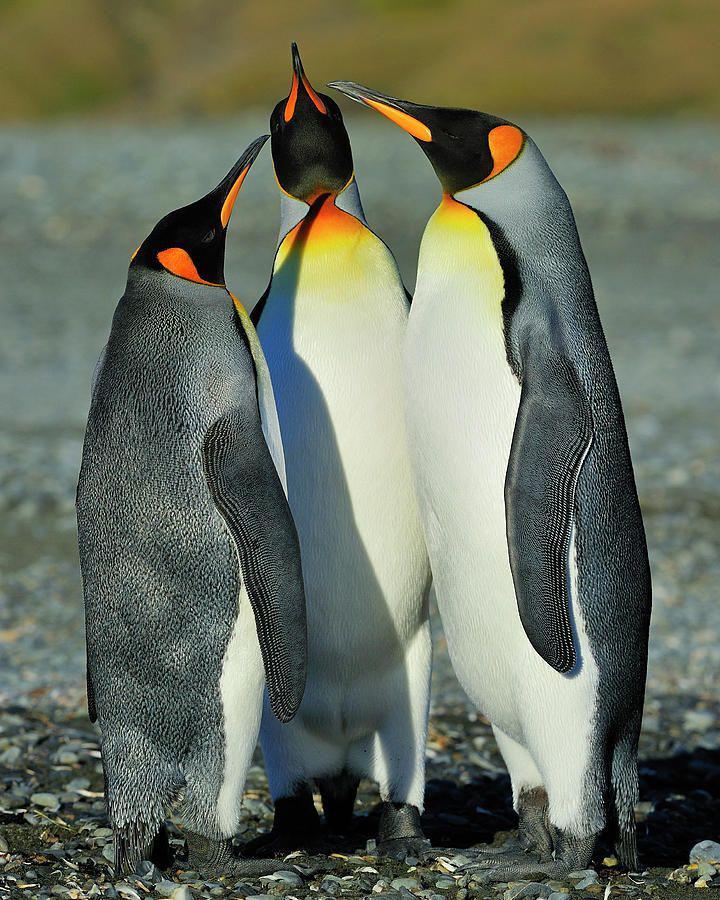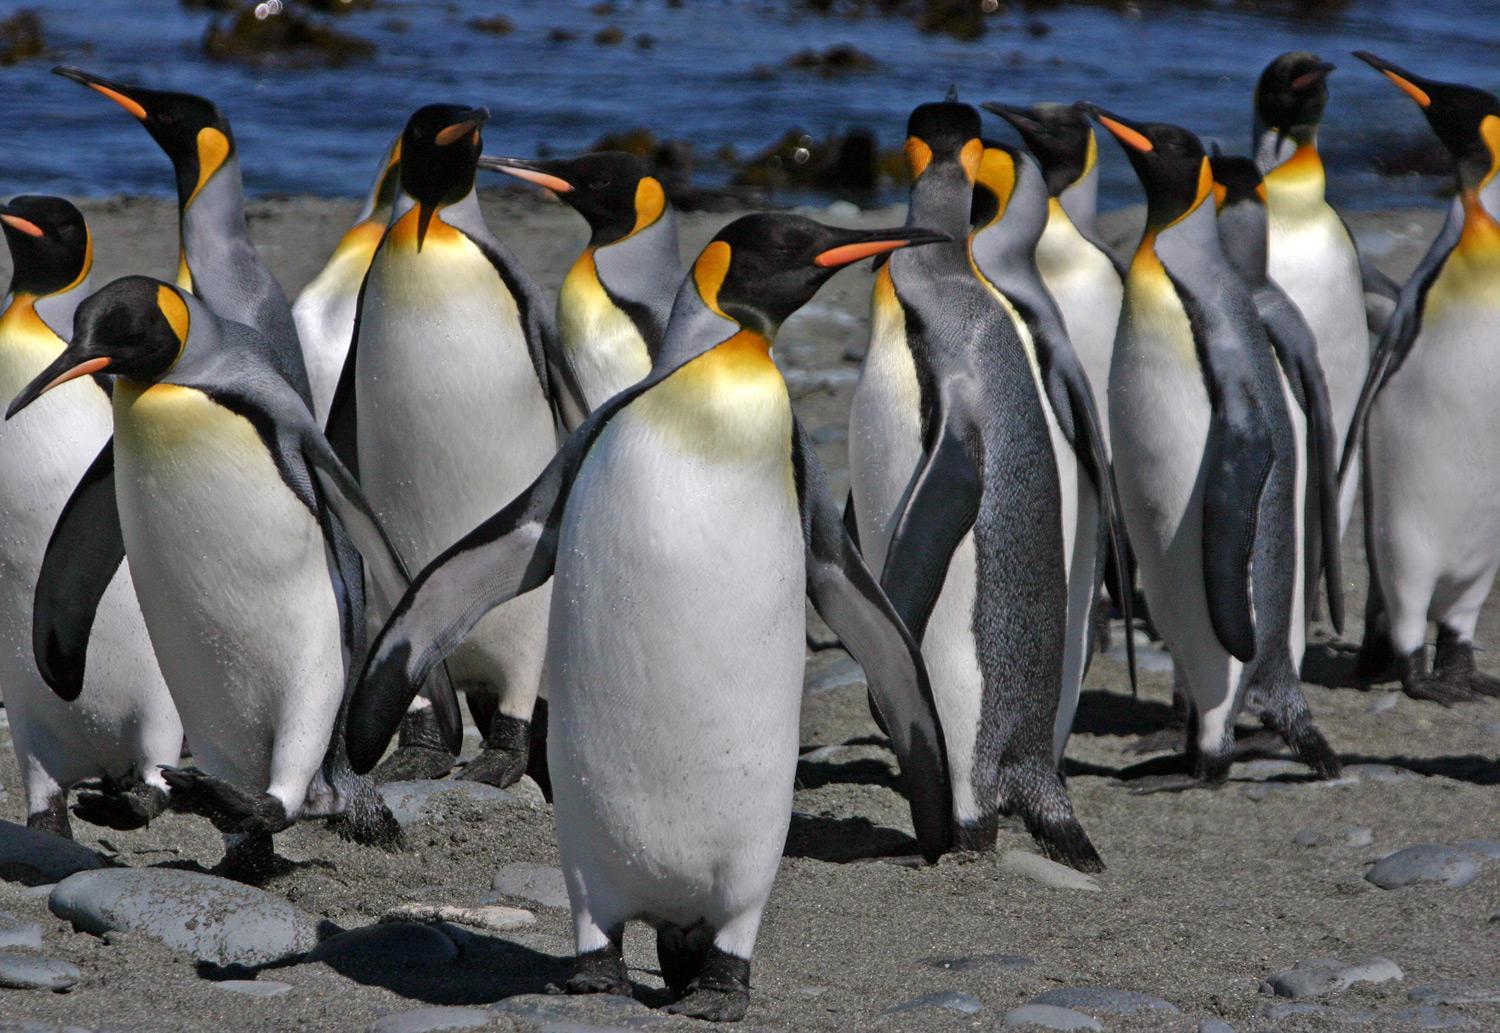The first image is the image on the left, the second image is the image on the right. Considering the images on both sides, is "1 of the penguins has brown fuzz on it." valid? Answer yes or no. No. 